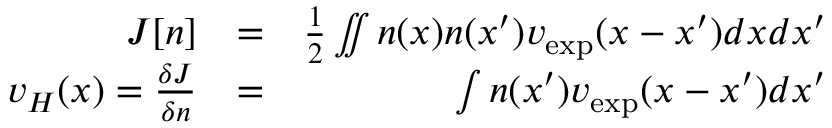Convert formula to latex. <formula><loc_0><loc_0><loc_500><loc_500>\begin{array} { r l r } { J [ n ] } & { = } & { \frac { 1 } { 2 } \iint n ( x ) n ( x ^ { \prime } ) v _ { e x p } ( x - x ^ { \prime } ) d x d x ^ { \prime } } \\ { v _ { H } ( x ) = \frac { \delta J } { \delta n } } & { = } & { \int n ( x ^ { \prime } ) v _ { e x p } ( x - x ^ { \prime } ) d x ^ { \prime } } \end{array}</formula> 